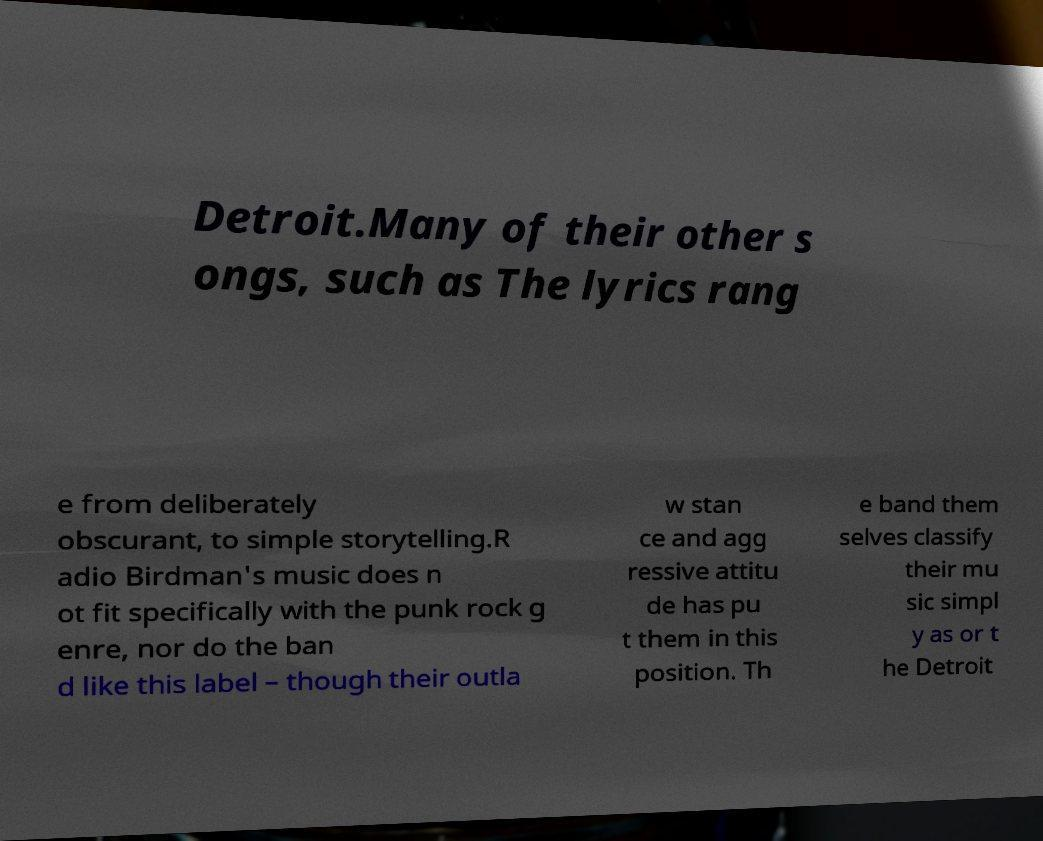What messages or text are displayed in this image? I need them in a readable, typed format. Detroit.Many of their other s ongs, such as The lyrics rang e from deliberately obscurant, to simple storytelling.R adio Birdman's music does n ot fit specifically with the punk rock g enre, nor do the ban d like this label – though their outla w stan ce and agg ressive attitu de has pu t them in this position. Th e band them selves classify their mu sic simpl y as or t he Detroit 